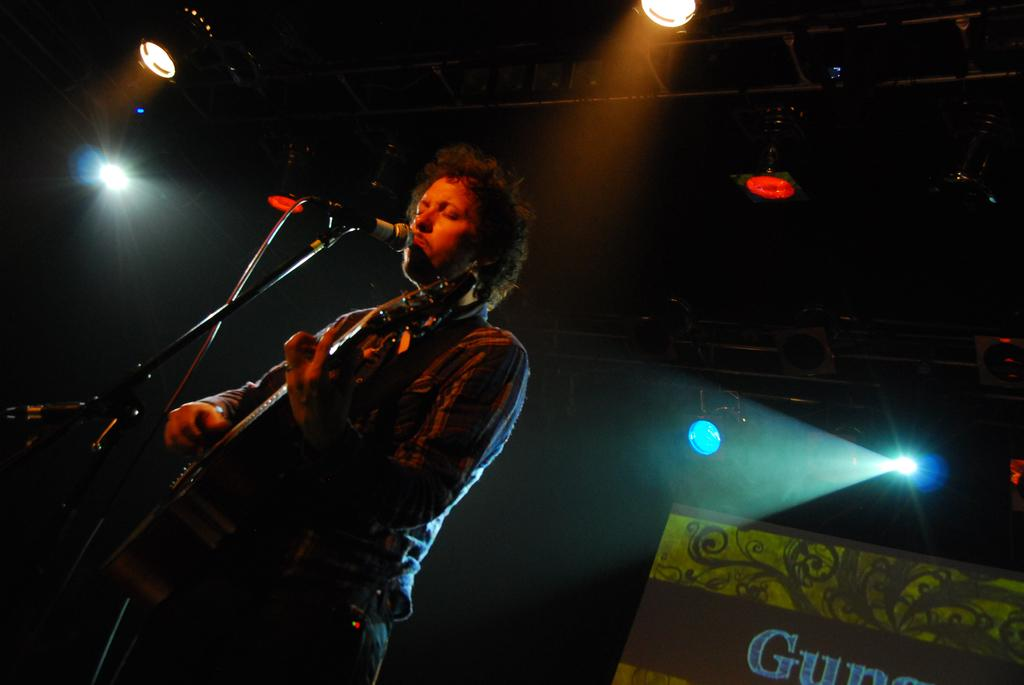What is the person in the image doing with the guitar? The person is playing the guitar. What is in front of the person while they are playing the guitar? There is a microphone and a microphone stand in front of the person. What can be seen in the right corner of the image? There is a banner in the right corner of the image. What type of lighting is visible in the image? There are lights visible in the image. What else can be seen in the image besides the person and their equipment? There are rods visible in the image. Are there any fairies visible in the image? No, there are no fairies present in the image. What type of weather condition is represented by the sleet in the image? There is no sleet present in the image; it is an absurd topic that does not relate to the image. 